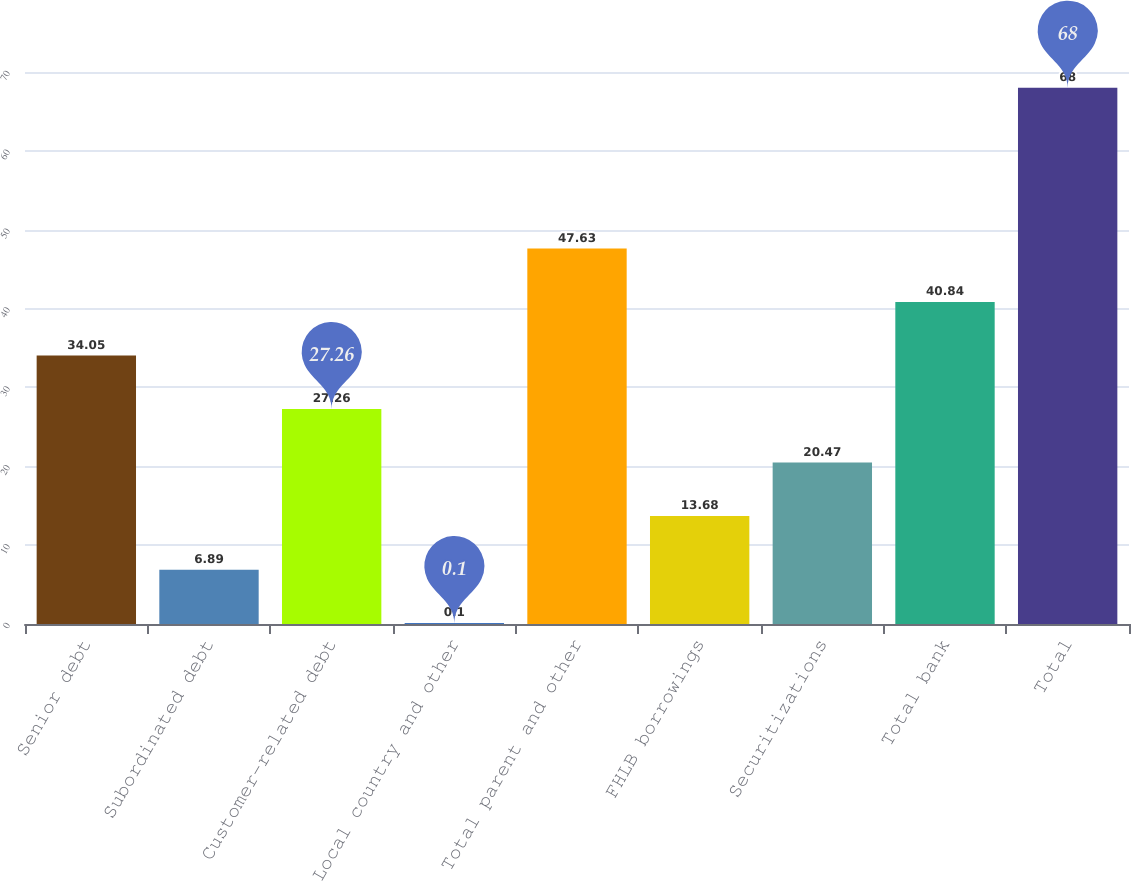Convert chart to OTSL. <chart><loc_0><loc_0><loc_500><loc_500><bar_chart><fcel>Senior debt<fcel>Subordinated debt<fcel>Customer-related debt<fcel>Local country and other<fcel>Total parent and other<fcel>FHLB borrowings<fcel>Securitizations<fcel>Total bank<fcel>Total<nl><fcel>34.05<fcel>6.89<fcel>27.26<fcel>0.1<fcel>47.63<fcel>13.68<fcel>20.47<fcel>40.84<fcel>68<nl></chart> 